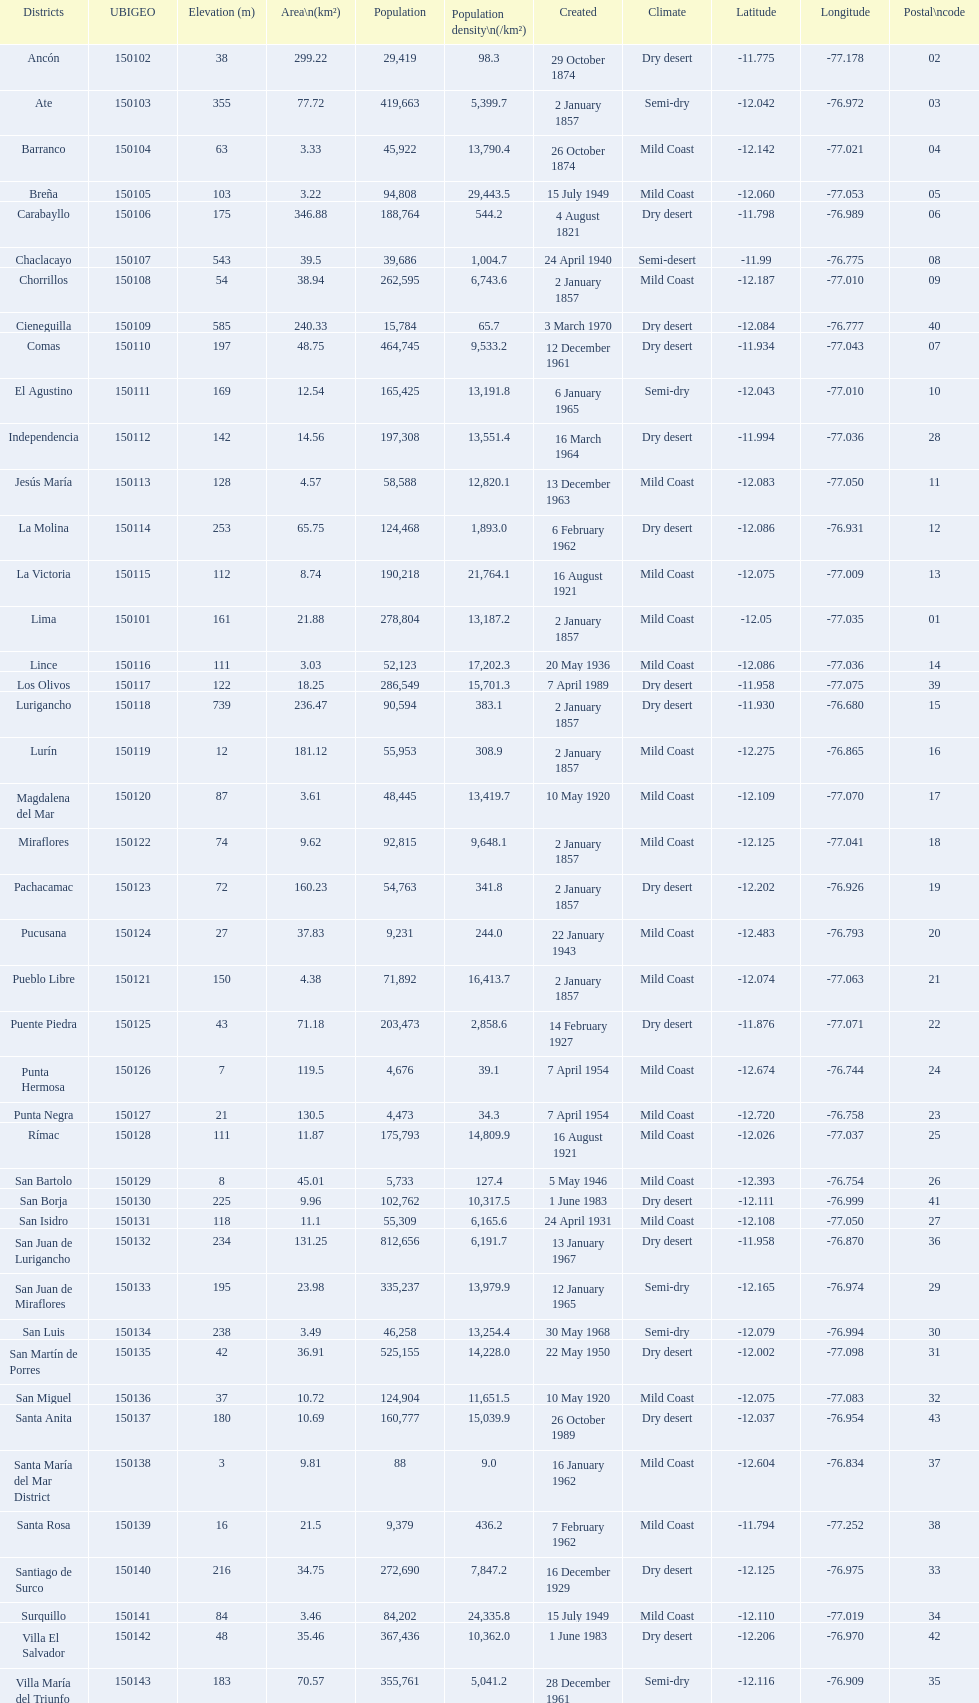Which district in this city has the greatest population? San Juan de Lurigancho. 